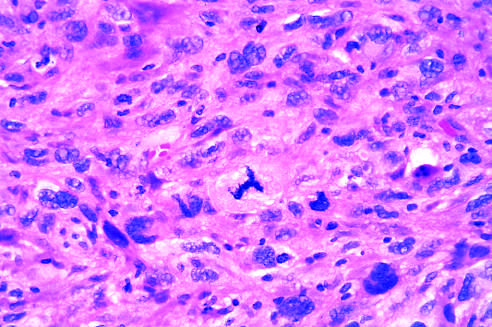do the majority of tissue macrophages show cellular and nuclear variation in size and shape?
Answer the question using a single word or phrase. No 